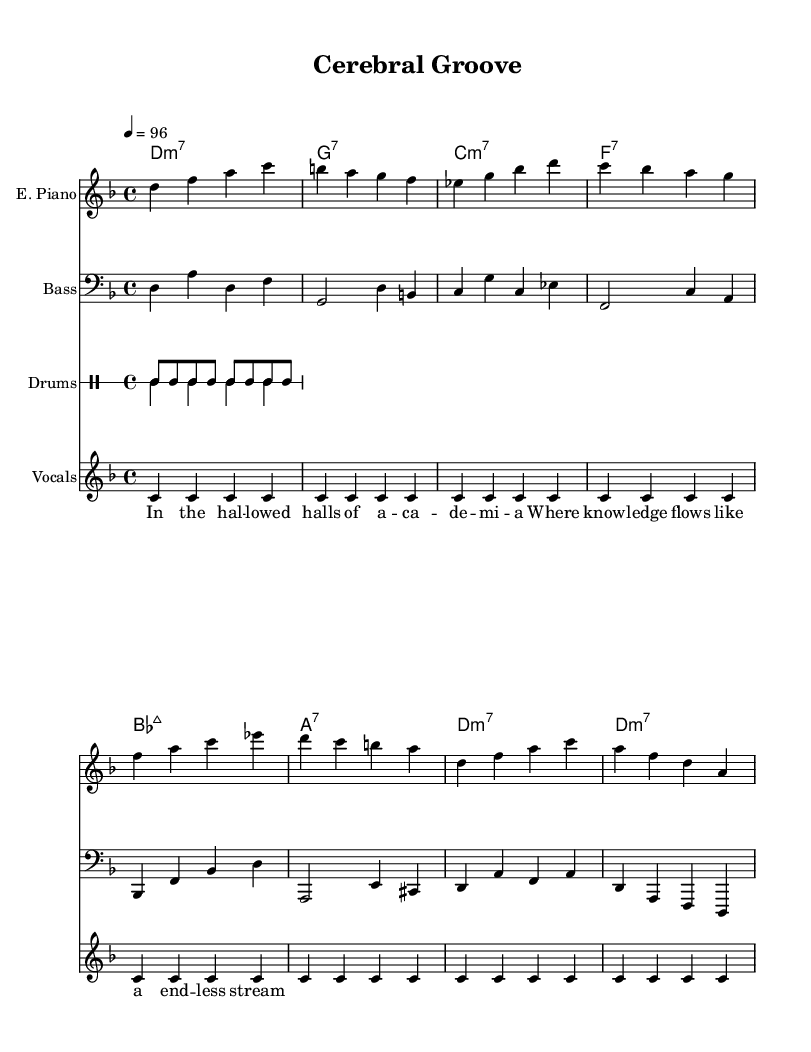What is the key signature of this music? The key signature indicated in the global section is D minor, which has one flat (B flat).
Answer: D minor What is the time signature of the piece? The time signature shown in the global section is four beats per measure, which is indicated as 4/4.
Answer: 4/4 What is the tempo marking for the piece? The tempo marking states that the piece should be played at 96 beats per minute, indicated as 4 equals 96.
Answer: 96 Which instrument is playing the bass line? The bass line is specifically notated in the bass staff, indicating that it is being played by the bass guitar.
Answer: Bass guitar How many measures are there in total? By counting all the measures in the electric piano part, bass part, and drum patterns, there are a total of eight measures throughout the score.
Answer: Eight What type of lyrics are used in the vocals? The lyrics feature philosophical themes, suggesting an intellectual approach typical of sophisticated funk.
Answer: Intellectual How does the drum pattern differentiate between up and down beats? The drum patterns are distinct, with the 'up' pattern using eighth notes and the 'down' pattern featuring a kick-snare combination, creating rhythm variation.
Answer: Rhythm variation 